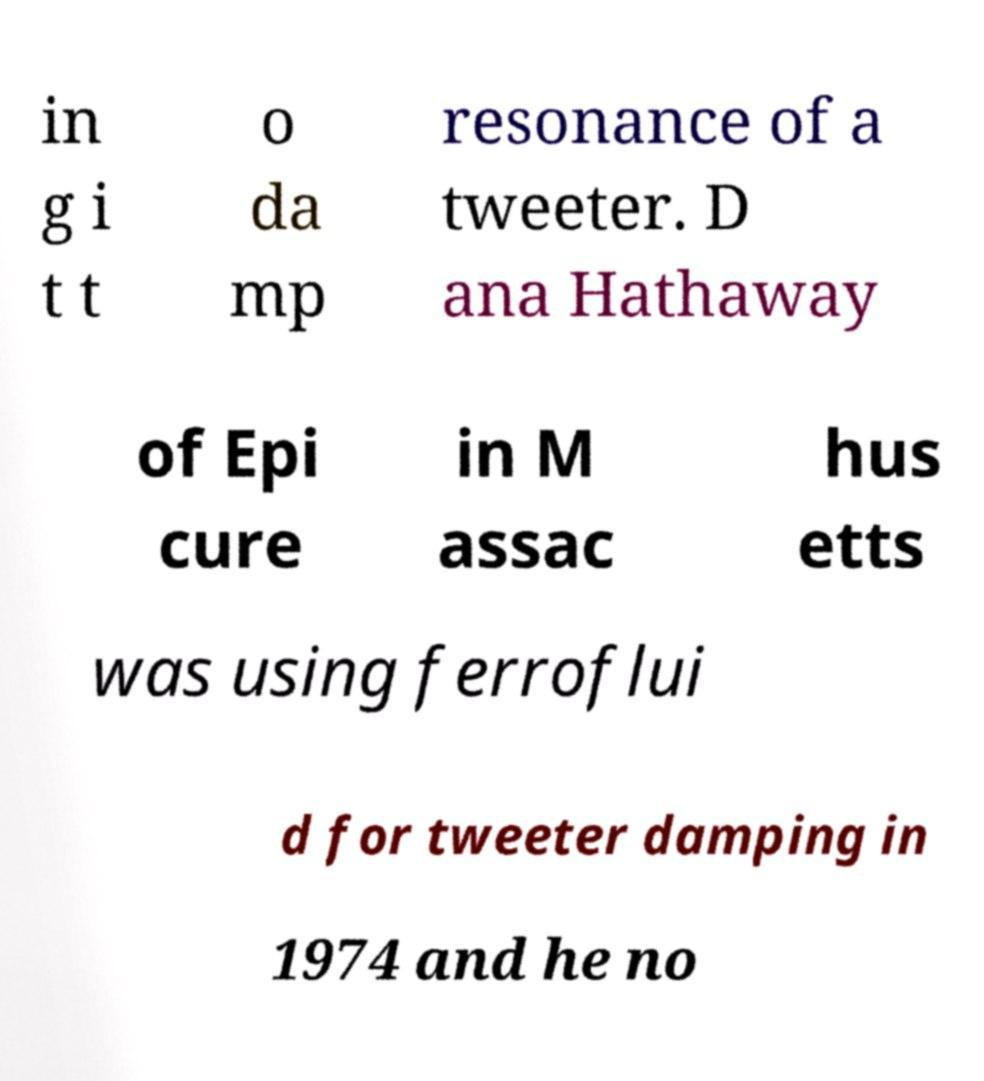What messages or text are displayed in this image? I need them in a readable, typed format. in g i t t o da mp resonance of a tweeter. D ana Hathaway of Epi cure in M assac hus etts was using ferroflui d for tweeter damping in 1974 and he no 